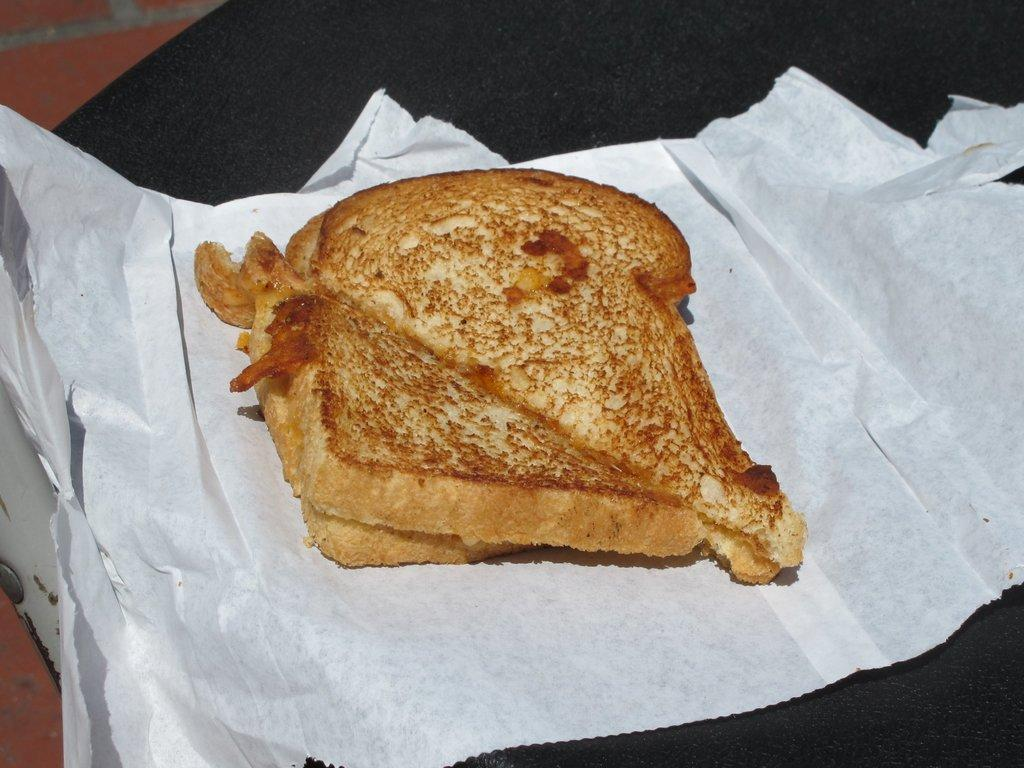What is the main subject of the image? The main subject of the image is food. How is the food presented in the image? The food is on a white paper. What is the color of the food? The food has a brown color. What is the color of the surface the food is on? The food is on a black surface. Can you see any flowers in the image? There are no flowers present in the image. 